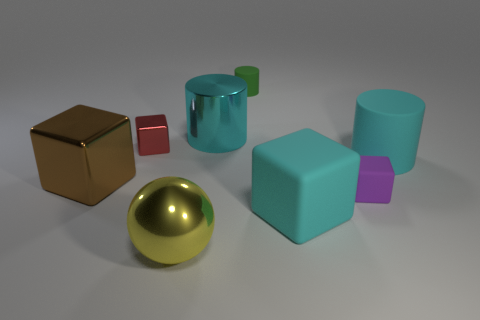Is there a thing of the same color as the big matte cylinder?
Give a very brief answer. Yes. There is a rubber object that is the same size as the purple cube; what is its color?
Your response must be concise. Green. There is a small block that is on the right side of the green matte thing; is there a thing that is left of it?
Provide a short and direct response. Yes. What is the tiny block in front of the red cube made of?
Ensure brevity in your answer.  Rubber. Is the material of the big block that is left of the small cylinder the same as the big cyan cylinder that is right of the green cylinder?
Give a very brief answer. No. Are there the same number of big objects that are behind the small red metallic thing and big cubes that are on the left side of the large yellow sphere?
Your answer should be very brief. Yes. How many tiny purple blocks have the same material as the small green cylinder?
Give a very brief answer. 1. What shape is the big rubber thing that is the same color as the large matte cylinder?
Offer a very short reply. Cube. There is a cylinder that is in front of the large metallic object that is behind the tiny red cube; what is its size?
Your answer should be compact. Large. Do the big shiny thing that is to the right of the big shiny ball and the small thing that is behind the large cyan metal cylinder have the same shape?
Offer a very short reply. Yes. 